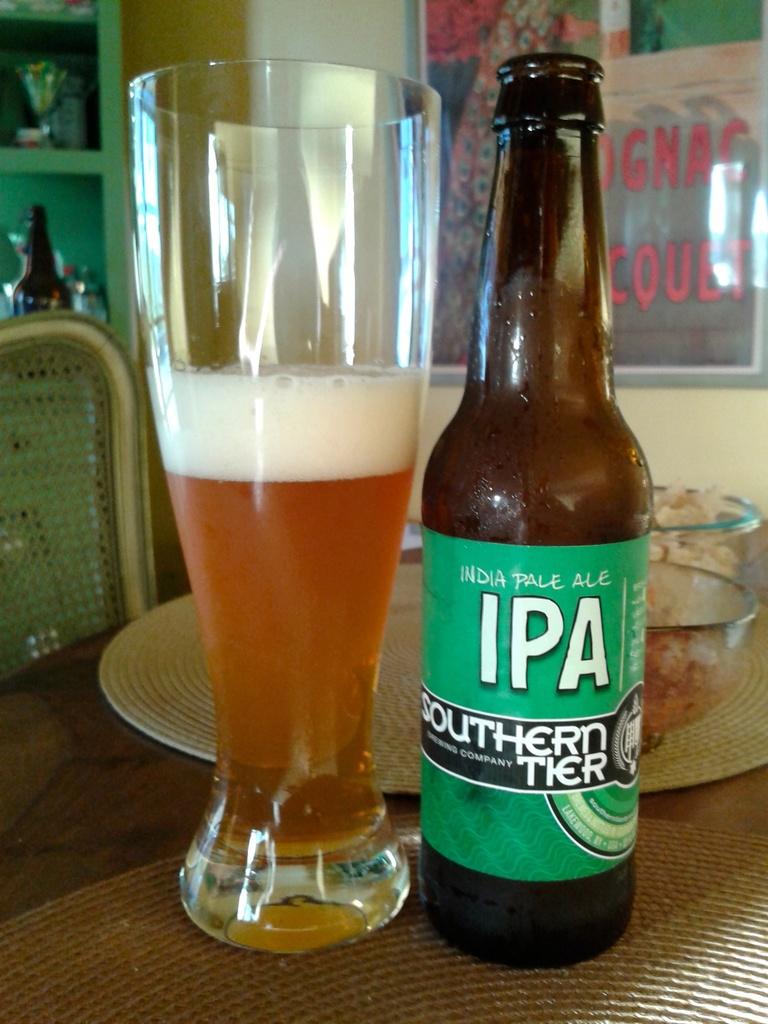What type of beer is in the bottle?
Offer a terse response. Ipa. Whats the brand of beer in the bottle?
Your response must be concise. Southern tier. 